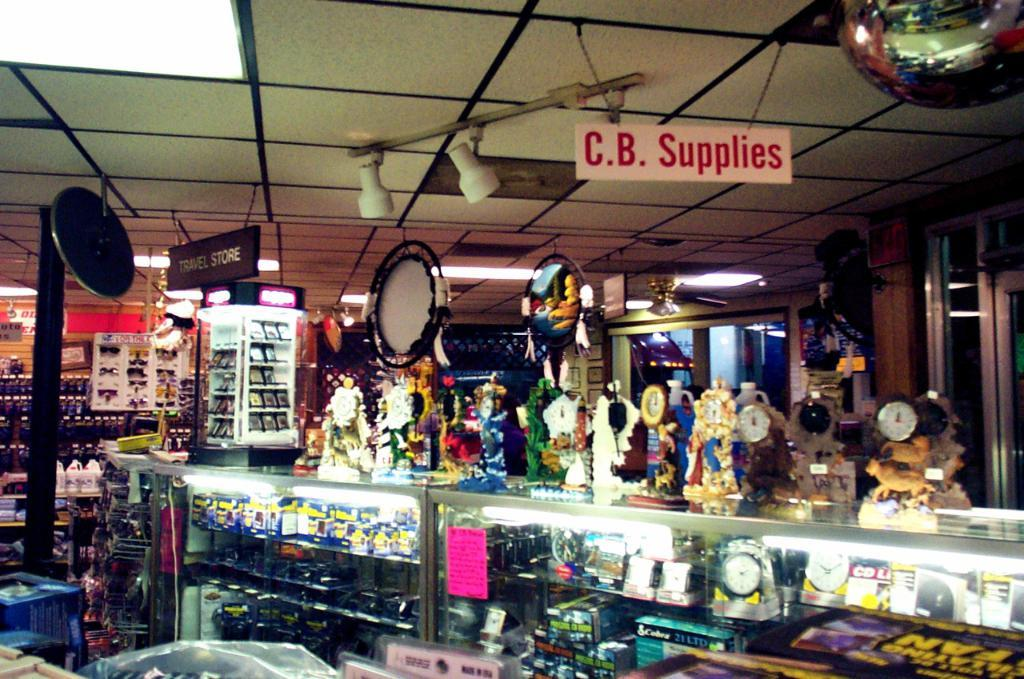Provide a one-sentence caption for the provided image. Store with a sign "C.B. Supplies" hanging from the ceiling. 